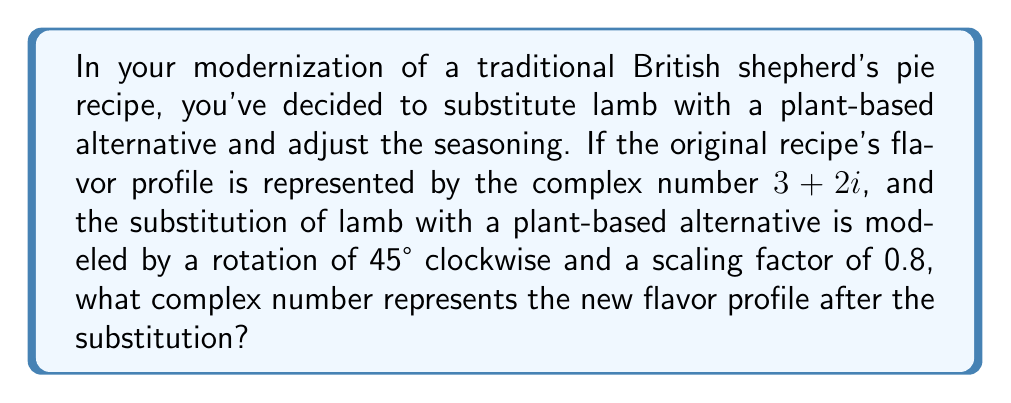Could you help me with this problem? Let's approach this step-by-step:

1) The original flavor profile is represented by $z = 3 + 2i$.

2) A rotation of 45° clockwise can be represented by multiplying by $e^{-i\pi/4}$ (negative sign for clockwise rotation).

3) The scaling factor of 0.8 is simply multiplied.

4) So, our transformation can be represented as:
   
   $z_{new} = 0.8 \cdot z \cdot e^{-i\pi/4}$

5) We can expand $e^{-i\pi/4}$ using Euler's formula:
   
   $e^{-i\pi/4} = \cos(-\pi/4) + i\sin(-\pi/4) = \frac{\sqrt{2}}{2} - i\frac{\sqrt{2}}{2}$

6) Now, let's multiply:
   
   $z_{new} = 0.8 \cdot (3 + 2i) \cdot (\frac{\sqrt{2}}{2} - i\frac{\sqrt{2}}{2})$

7) Distributing:
   
   $z_{new} = 0.8 \cdot ((3 + 2i)(\frac{\sqrt{2}}{2}) - (3 + 2i)(i\frac{\sqrt{2}}{2}))$
   
   $= 0.8 \cdot ((\frac{3\sqrt{2}}{2} + i\sqrt{2}) - (3i\frac{\sqrt{2}}{2} - \sqrt{2}))$
   
   $= 0.8 \cdot (\frac{3\sqrt{2}}{2} + \sqrt{2} + i\sqrt{2} - 3i\frac{\sqrt{2}}{2})$

8) Combining real and imaginary parts:
   
   $z_{new} = 0.8 \cdot (\frac{5\sqrt{2}}{2} - i\frac{\sqrt{2}}{2})$

9) Multiplying by 0.8:
   
   $z_{new} = 2\sqrt{2} - i\frac{\sqrt{2}}{2}$

10) This can be approximated as:
    
    $z_{new} \approx 2.83 - 0.71i$
Answer: $2\sqrt{2} - i\frac{\sqrt{2}}{2}$ 